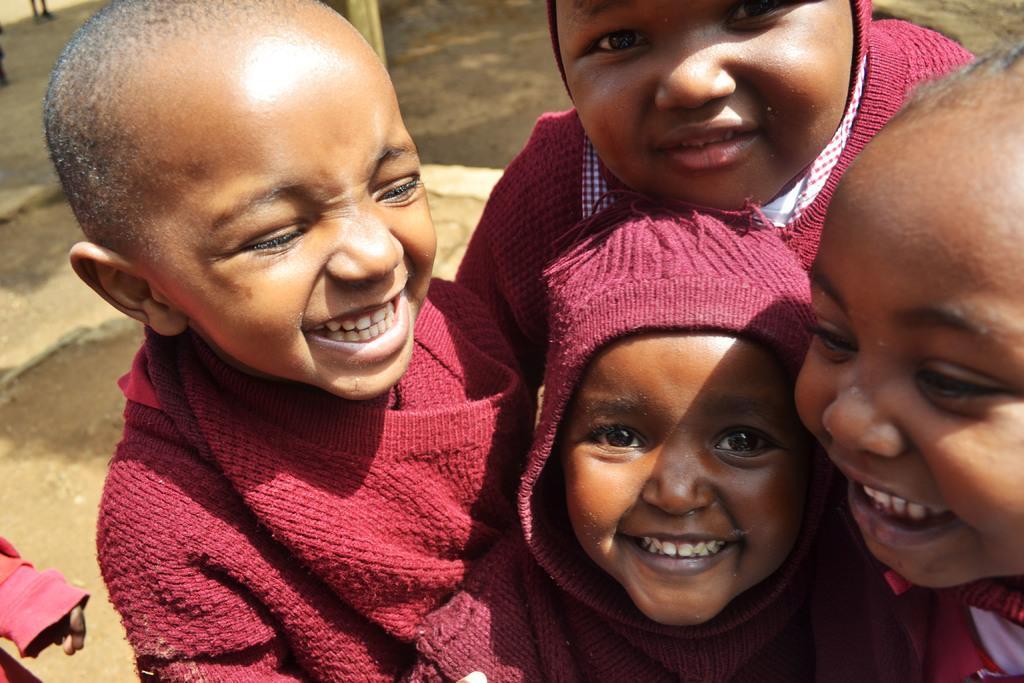Can you describe this image briefly? In this image there are kids standing. They are smiling. Behind them there is the ground. 